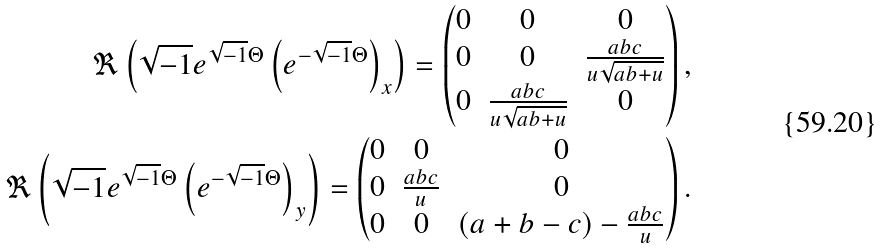<formula> <loc_0><loc_0><loc_500><loc_500>\Re \left ( \sqrt { - 1 } e ^ { \sqrt { - 1 } \Theta } \left ( e ^ { - \sqrt { - 1 } \Theta } \right ) _ { x } \right ) = \begin{pmatrix} 0 & 0 & 0 \\ 0 & 0 & \frac { a b c } { u \sqrt { a b + u } } \\ 0 & \frac { a b c } { u \sqrt { a b + u } } & 0 \end{pmatrix} , \\ \Re \left ( \sqrt { - 1 } e ^ { \sqrt { - 1 } \Theta } \left ( e ^ { - \sqrt { - 1 } \Theta } \right ) _ { y } \right ) = \begin{pmatrix} 0 & 0 & 0 \\ 0 & \frac { a b c } { u } & 0 \\ 0 & 0 & ( a + b - c ) - \frac { a b c } { u } \end{pmatrix} .</formula> 